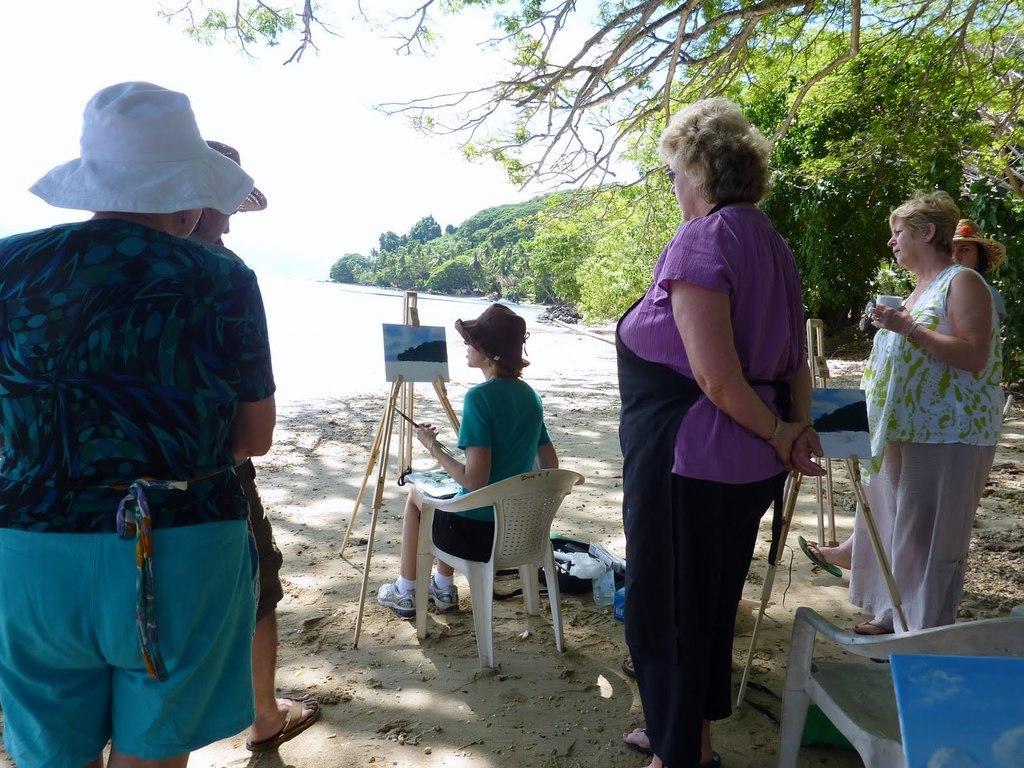How would you summarize this image in a sentence or two? As we can see in the image there is a sky, few people standing over here and there is a woman sitting on chair. 